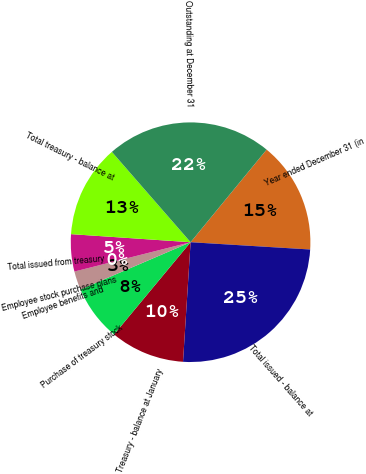Convert chart to OTSL. <chart><loc_0><loc_0><loc_500><loc_500><pie_chart><fcel>Year ended December 31 (in<fcel>Total issued - balance at<fcel>Treasury - balance at January<fcel>Purchase of treasury stock<fcel>Employee benefits and<fcel>Employee stock purchase plans<fcel>Total issued from treasury<fcel>Total treasury - balance at<fcel>Outstanding at December 31<nl><fcel>15.03%<fcel>25.04%<fcel>10.02%<fcel>7.52%<fcel>2.51%<fcel>0.01%<fcel>5.01%<fcel>12.52%<fcel>22.35%<nl></chart> 